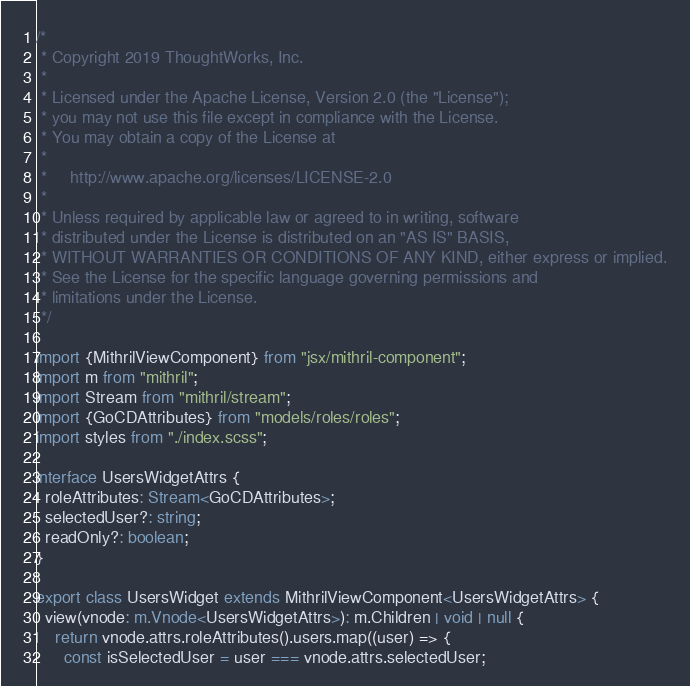Convert code to text. <code><loc_0><loc_0><loc_500><loc_500><_TypeScript_>/*
 * Copyright 2019 ThoughtWorks, Inc.
 *
 * Licensed under the Apache License, Version 2.0 (the "License");
 * you may not use this file except in compliance with the License.
 * You may obtain a copy of the License at
 *
 *     http://www.apache.org/licenses/LICENSE-2.0
 *
 * Unless required by applicable law or agreed to in writing, software
 * distributed under the License is distributed on an "AS IS" BASIS,
 * WITHOUT WARRANTIES OR CONDITIONS OF ANY KIND, either express or implied.
 * See the License for the specific language governing permissions and
 * limitations under the License.
 */

import {MithrilViewComponent} from "jsx/mithril-component";
import m from "mithril";
import Stream from "mithril/stream";
import {GoCDAttributes} from "models/roles/roles";
import styles from "./index.scss";

interface UsersWidgetAttrs {
  roleAttributes: Stream<GoCDAttributes>;
  selectedUser?: string;
  readOnly?: boolean;
}

export class UsersWidget extends MithrilViewComponent<UsersWidgetAttrs> {
  view(vnode: m.Vnode<UsersWidgetAttrs>): m.Children | void | null {
    return vnode.attrs.roleAttributes().users.map((user) => {
      const isSelectedUser = user === vnode.attrs.selectedUser;</code> 